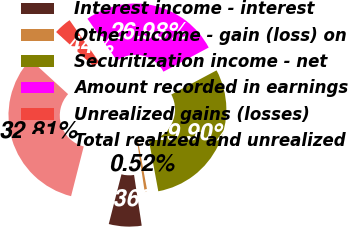<chart> <loc_0><loc_0><loc_500><loc_500><pie_chart><fcel>Interest income - interest<fcel>Other income - gain (loss) on<fcel>Securitization income - net<fcel>Amount recorded in earnings<fcel>Unrealized gains (losses)<fcel>Total realized and unrealized<nl><fcel>6.36%<fcel>0.52%<fcel>29.9%<fcel>26.98%<fcel>3.44%<fcel>32.81%<nl></chart> 